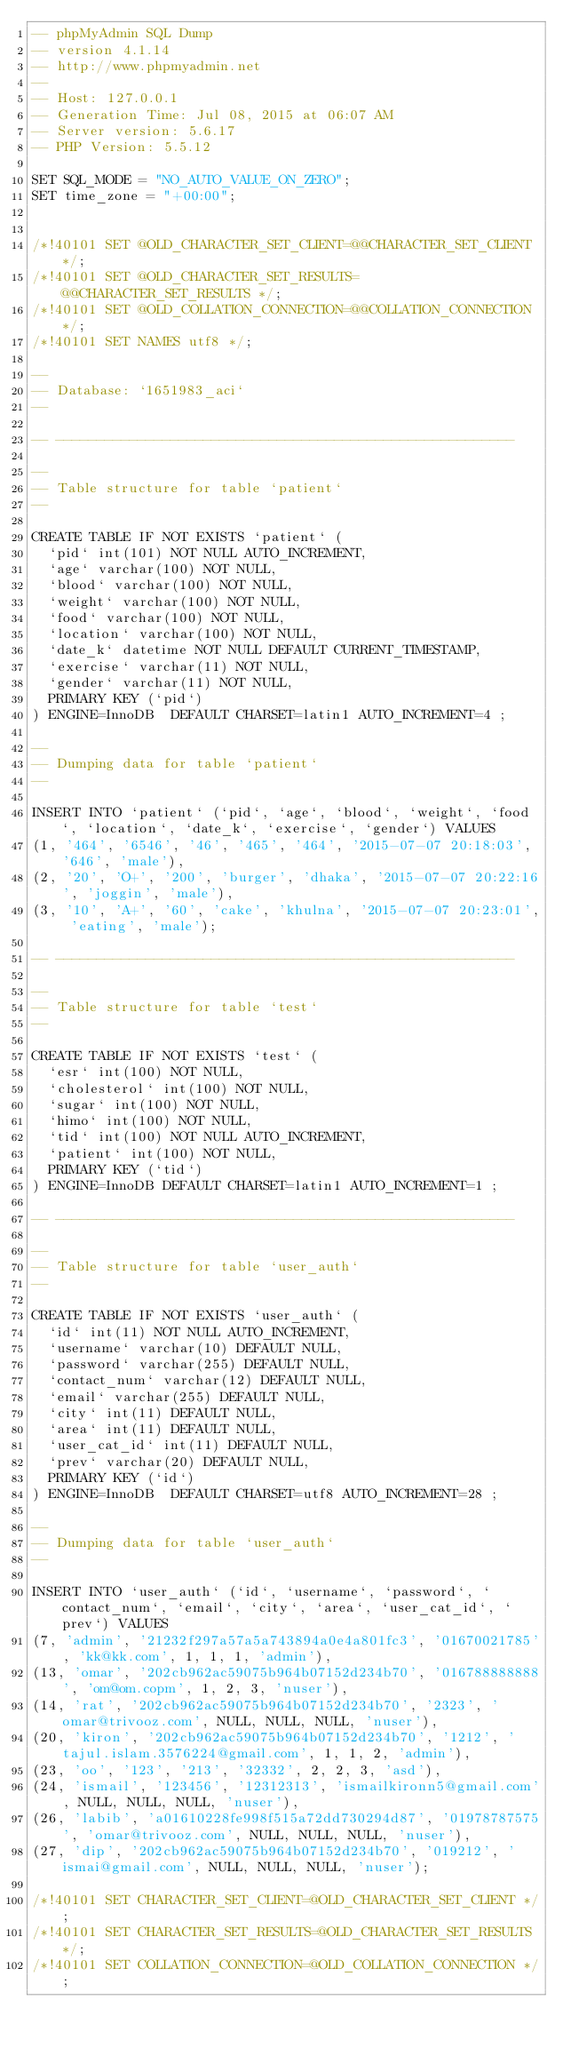Convert code to text. <code><loc_0><loc_0><loc_500><loc_500><_SQL_>-- phpMyAdmin SQL Dump
-- version 4.1.14
-- http://www.phpmyadmin.net
--
-- Host: 127.0.0.1
-- Generation Time: Jul 08, 2015 at 06:07 AM
-- Server version: 5.6.17
-- PHP Version: 5.5.12

SET SQL_MODE = "NO_AUTO_VALUE_ON_ZERO";
SET time_zone = "+00:00";


/*!40101 SET @OLD_CHARACTER_SET_CLIENT=@@CHARACTER_SET_CLIENT */;
/*!40101 SET @OLD_CHARACTER_SET_RESULTS=@@CHARACTER_SET_RESULTS */;
/*!40101 SET @OLD_COLLATION_CONNECTION=@@COLLATION_CONNECTION */;
/*!40101 SET NAMES utf8 */;

--
-- Database: `1651983_aci`
--

-- --------------------------------------------------------

--
-- Table structure for table `patient`
--

CREATE TABLE IF NOT EXISTS `patient` (
  `pid` int(101) NOT NULL AUTO_INCREMENT,
  `age` varchar(100) NOT NULL,
  `blood` varchar(100) NOT NULL,
  `weight` varchar(100) NOT NULL,
  `food` varchar(100) NOT NULL,
  `location` varchar(100) NOT NULL,
  `date_k` datetime NOT NULL DEFAULT CURRENT_TIMESTAMP,
  `exercise` varchar(11) NOT NULL,
  `gender` varchar(11) NOT NULL,
  PRIMARY KEY (`pid`)
) ENGINE=InnoDB  DEFAULT CHARSET=latin1 AUTO_INCREMENT=4 ;

--
-- Dumping data for table `patient`
--

INSERT INTO `patient` (`pid`, `age`, `blood`, `weight`, `food`, `location`, `date_k`, `exercise`, `gender`) VALUES
(1, '464', '6546', '46', '465', '464', '2015-07-07 20:18:03', '646', 'male'),
(2, '20', 'O+', '200', 'burger', 'dhaka', '2015-07-07 20:22:16', 'joggin', 'male'),
(3, '10', 'A+', '60', 'cake', 'khulna', '2015-07-07 20:23:01', 'eating', 'male');

-- --------------------------------------------------------

--
-- Table structure for table `test`
--

CREATE TABLE IF NOT EXISTS `test` (
  `esr` int(100) NOT NULL,
  `cholesterol` int(100) NOT NULL,
  `sugar` int(100) NOT NULL,
  `himo` int(100) NOT NULL,
  `tid` int(100) NOT NULL AUTO_INCREMENT,
  `patient` int(100) NOT NULL,
  PRIMARY KEY (`tid`)
) ENGINE=InnoDB DEFAULT CHARSET=latin1 AUTO_INCREMENT=1 ;

-- --------------------------------------------------------

--
-- Table structure for table `user_auth`
--

CREATE TABLE IF NOT EXISTS `user_auth` (
  `id` int(11) NOT NULL AUTO_INCREMENT,
  `username` varchar(10) DEFAULT NULL,
  `password` varchar(255) DEFAULT NULL,
  `contact_num` varchar(12) DEFAULT NULL,
  `email` varchar(255) DEFAULT NULL,
  `city` int(11) DEFAULT NULL,
  `area` int(11) DEFAULT NULL,
  `user_cat_id` int(11) DEFAULT NULL,
  `prev` varchar(20) DEFAULT NULL,
  PRIMARY KEY (`id`)
) ENGINE=InnoDB  DEFAULT CHARSET=utf8 AUTO_INCREMENT=28 ;

--
-- Dumping data for table `user_auth`
--

INSERT INTO `user_auth` (`id`, `username`, `password`, `contact_num`, `email`, `city`, `area`, `user_cat_id`, `prev`) VALUES
(7, 'admin', '21232f297a57a5a743894a0e4a801fc3', '01670021785', 'kk@kk.com', 1, 1, 1, 'admin'),
(13, 'omar', '202cb962ac59075b964b07152d234b70', '016788888888', 'om@om.copm', 1, 2, 3, 'nuser'),
(14, 'rat', '202cb962ac59075b964b07152d234b70', '2323', 'omar@trivooz.com', NULL, NULL, NULL, 'nuser'),
(20, 'kiron', '202cb962ac59075b964b07152d234b70', '1212', 'tajul.islam.3576224@gmail.com', 1, 1, 2, 'admin'),
(23, 'oo', '123', '213', '32332', 2, 2, 3, 'asd'),
(24, 'ismail', '123456', '12312313', 'ismailkironn5@gmail.com', NULL, NULL, NULL, 'nuser'),
(26, 'labib', 'a01610228fe998f515a72dd730294d87', '01978787575', 'omar@trivooz.com', NULL, NULL, NULL, 'nuser'),
(27, 'dip', '202cb962ac59075b964b07152d234b70', '019212', 'ismai@gmail.com', NULL, NULL, NULL, 'nuser');

/*!40101 SET CHARACTER_SET_CLIENT=@OLD_CHARACTER_SET_CLIENT */;
/*!40101 SET CHARACTER_SET_RESULTS=@OLD_CHARACTER_SET_RESULTS */;
/*!40101 SET COLLATION_CONNECTION=@OLD_COLLATION_CONNECTION */;
</code> 